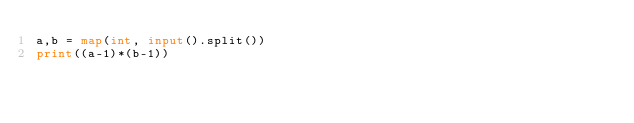<code> <loc_0><loc_0><loc_500><loc_500><_Python_>a,b = map(int, input().split())
print((a-1)*(b-1))</code> 